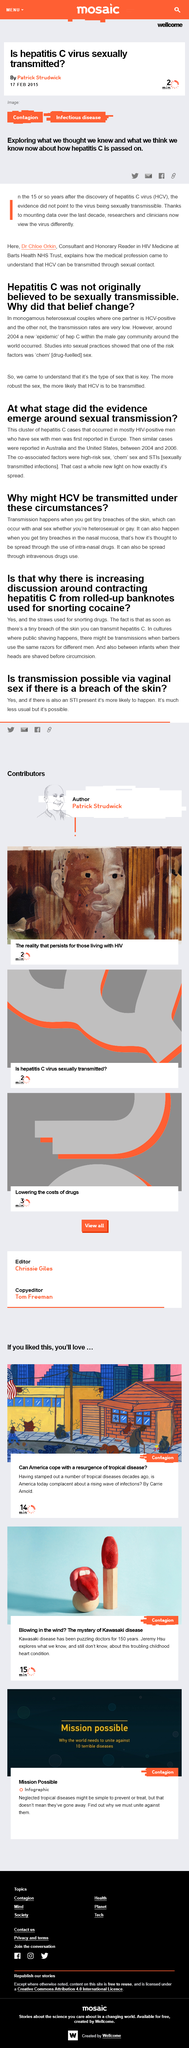Mention a couple of crucial points in this snapshot. It was originally believed that Hepatitis C was not sexually transmissible because transmission rates were low in monogamous, heterosexual couples. One of the risk factors for the transmission of hepatitis C was engaging in sexual practices that involved the use of drugs, commonly referred to as "chem" sex. Hepatitis C Virus is known by the acronym HCV. In 2004, a new "epidemic" of hepatitis C (HCV) began within the male gay community around the world. The article entitled "Is Hepatitis C virus sexually transmitted?" published on February 17, 2015, was authored by Patrick Strudwick. 